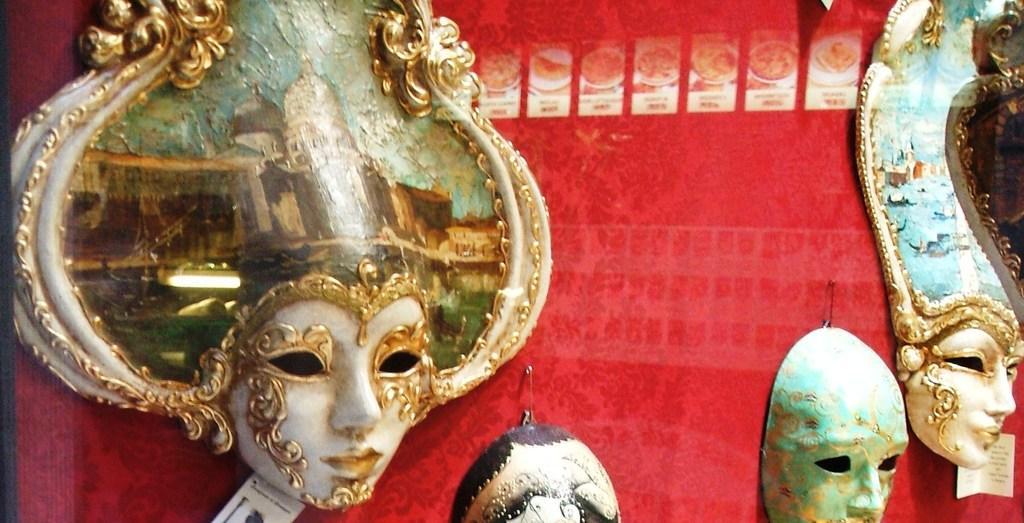Describe this image in one or two sentences. In this picture we can see there are masks and safety pins on a red object. 